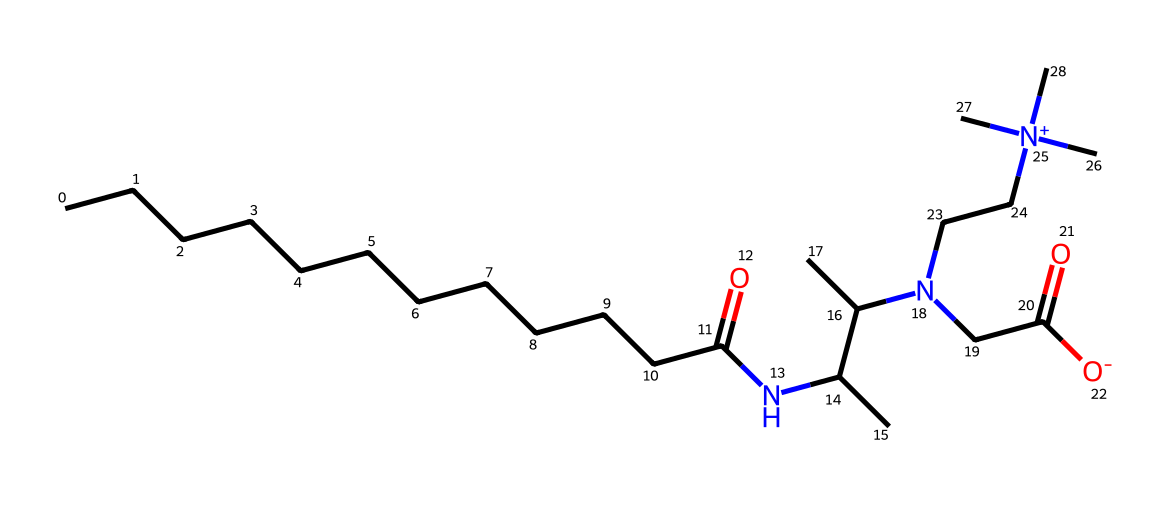What is the total number of nitrogen atoms in this chemical? To find the number of nitrogen atoms, we can look for the nitrogen (N) symbols in the SMILES representation. There are two nitrogen atoms present in the chemical structure.
Answer: 2 What functional group is indicated by the "NC" segment in the structure? The "NC" part suggests the presence of an amine functional group, which contains a nitrogen atom bonded to carbon atoms.
Answer: amine How many carbon atoms are present in this molecule? By counting the "C" symbols in the SMILES string, we find there are a total of 14 carbon atoms within the structure.
Answer: 14 Does this chemical have any charged groups? The "[N+]" notation in the SMILES indicates a positively charged nitrogen, demonstrating that the molecule has a charged group.
Answer: yes What property does the presence of both hydrophobic and hydrophilic components indicate about this surfactant? The coexistence of long carbon chains (hydrophobic) and ionic groups (hydrophilic) suggests that this compound functions as an amphoteric surfactant, enabling it to reduce surface tension in cleaning applications.
Answer: amphoteric Which part of the chemical structure ensures its efficacy in cleaning equipment? The long hydrophobic carbon chain helps to dissolve grease and oils, while the hydrophilic groups allow the surfactant to interact with water, enhancing its cleaning capability.
Answer: hydrophobic chain What type of surfactant is cocamidopropyl betaine classified as? The structure reveals the presence of both ionic and non-ionic characteristics, indicating that it is classified as an amphoteric surfactant, which can behave as either a cation or an anion depending on the pH.
Answer: amphoteric 